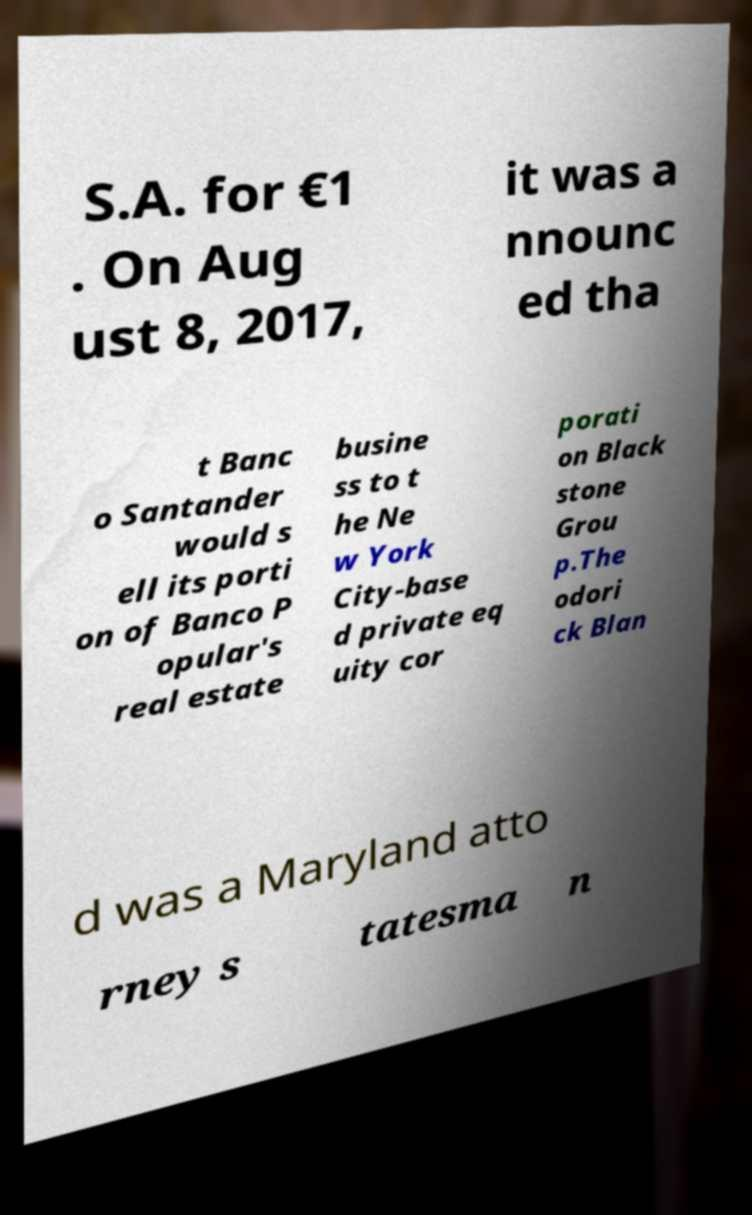I need the written content from this picture converted into text. Can you do that? S.A. for €1 . On Aug ust 8, 2017, it was a nnounc ed tha t Banc o Santander would s ell its porti on of Banco P opular's real estate busine ss to t he Ne w York City-base d private eq uity cor porati on Black stone Grou p.The odori ck Blan d was a Maryland atto rney s tatesma n 